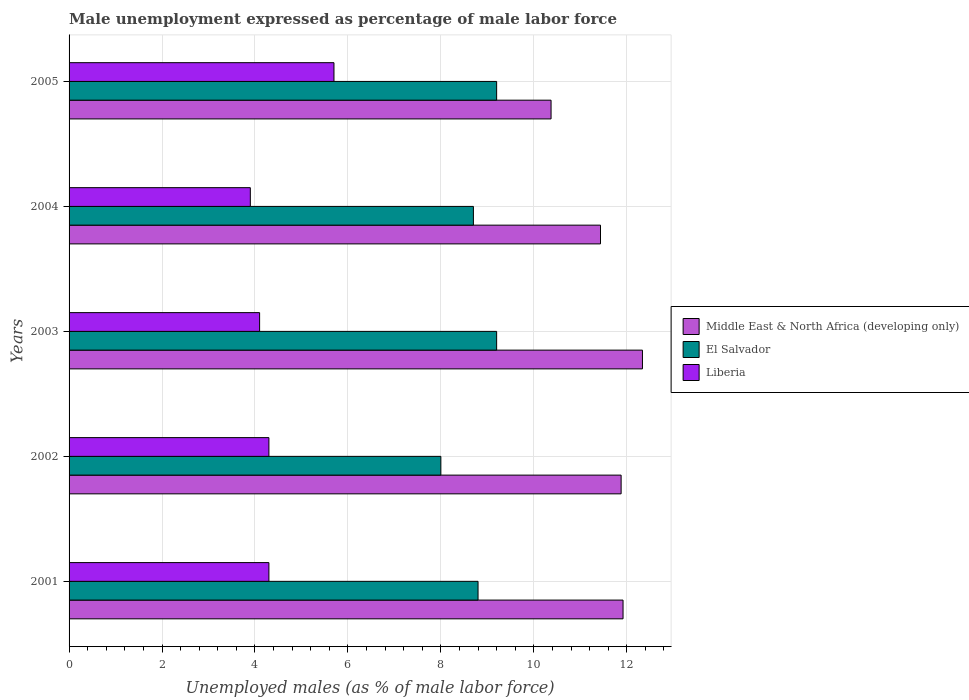How many different coloured bars are there?
Your answer should be compact. 3. What is the label of the 3rd group of bars from the top?
Your answer should be compact. 2003. In how many cases, is the number of bars for a given year not equal to the number of legend labels?
Your response must be concise. 0. What is the unemployment in males in in Middle East & North Africa (developing only) in 2005?
Offer a terse response. 10.37. Across all years, what is the maximum unemployment in males in in Liberia?
Give a very brief answer. 5.7. Across all years, what is the minimum unemployment in males in in Middle East & North Africa (developing only)?
Your answer should be very brief. 10.37. What is the total unemployment in males in in El Salvador in the graph?
Provide a short and direct response. 43.9. What is the difference between the unemployment in males in in El Salvador in 2001 and that in 2002?
Provide a short and direct response. 0.8. What is the difference between the unemployment in males in in Liberia in 2001 and the unemployment in males in in Middle East & North Africa (developing only) in 2002?
Your answer should be very brief. -7.58. What is the average unemployment in males in in El Salvador per year?
Your answer should be compact. 8.78. In the year 2002, what is the difference between the unemployment in males in in Liberia and unemployment in males in in El Salvador?
Offer a very short reply. -3.7. In how many years, is the unemployment in males in in El Salvador greater than 1.2000000000000002 %?
Ensure brevity in your answer.  5. What is the ratio of the unemployment in males in in Middle East & North Africa (developing only) in 2001 to that in 2005?
Offer a terse response. 1.15. Is the unemployment in males in in El Salvador in 2003 less than that in 2005?
Provide a succinct answer. No. Is the difference between the unemployment in males in in Liberia in 2003 and 2004 greater than the difference between the unemployment in males in in El Salvador in 2003 and 2004?
Offer a very short reply. No. What is the difference between the highest and the lowest unemployment in males in in El Salvador?
Your answer should be very brief. 1.2. In how many years, is the unemployment in males in in Liberia greater than the average unemployment in males in in Liberia taken over all years?
Give a very brief answer. 1. Is the sum of the unemployment in males in in Liberia in 2003 and 2005 greater than the maximum unemployment in males in in El Salvador across all years?
Keep it short and to the point. Yes. What does the 3rd bar from the top in 2003 represents?
Offer a terse response. Middle East & North Africa (developing only). What does the 2nd bar from the bottom in 2001 represents?
Offer a very short reply. El Salvador. Is it the case that in every year, the sum of the unemployment in males in in El Salvador and unemployment in males in in Middle East & North Africa (developing only) is greater than the unemployment in males in in Liberia?
Keep it short and to the point. Yes. Are all the bars in the graph horizontal?
Keep it short and to the point. Yes. How many years are there in the graph?
Provide a succinct answer. 5. What is the difference between two consecutive major ticks on the X-axis?
Provide a short and direct response. 2. Are the values on the major ticks of X-axis written in scientific E-notation?
Your response must be concise. No. Does the graph contain any zero values?
Your answer should be very brief. No. Does the graph contain grids?
Your response must be concise. Yes. How are the legend labels stacked?
Your response must be concise. Vertical. What is the title of the graph?
Keep it short and to the point. Male unemployment expressed as percentage of male labor force. What is the label or title of the X-axis?
Give a very brief answer. Unemployed males (as % of male labor force). What is the label or title of the Y-axis?
Provide a short and direct response. Years. What is the Unemployed males (as % of male labor force) in Middle East & North Africa (developing only) in 2001?
Offer a terse response. 11.92. What is the Unemployed males (as % of male labor force) in El Salvador in 2001?
Offer a terse response. 8.8. What is the Unemployed males (as % of male labor force) in Liberia in 2001?
Provide a succinct answer. 4.3. What is the Unemployed males (as % of male labor force) in Middle East & North Africa (developing only) in 2002?
Ensure brevity in your answer.  11.88. What is the Unemployed males (as % of male labor force) in Liberia in 2002?
Offer a terse response. 4.3. What is the Unemployed males (as % of male labor force) of Middle East & North Africa (developing only) in 2003?
Your response must be concise. 12.34. What is the Unemployed males (as % of male labor force) of El Salvador in 2003?
Your response must be concise. 9.2. What is the Unemployed males (as % of male labor force) of Liberia in 2003?
Your answer should be very brief. 4.1. What is the Unemployed males (as % of male labor force) of Middle East & North Africa (developing only) in 2004?
Ensure brevity in your answer.  11.43. What is the Unemployed males (as % of male labor force) in El Salvador in 2004?
Provide a short and direct response. 8.7. What is the Unemployed males (as % of male labor force) of Liberia in 2004?
Provide a short and direct response. 3.9. What is the Unemployed males (as % of male labor force) of Middle East & North Africa (developing only) in 2005?
Make the answer very short. 10.37. What is the Unemployed males (as % of male labor force) in El Salvador in 2005?
Your answer should be compact. 9.2. What is the Unemployed males (as % of male labor force) of Liberia in 2005?
Provide a succinct answer. 5.7. Across all years, what is the maximum Unemployed males (as % of male labor force) in Middle East & North Africa (developing only)?
Your response must be concise. 12.34. Across all years, what is the maximum Unemployed males (as % of male labor force) in El Salvador?
Ensure brevity in your answer.  9.2. Across all years, what is the maximum Unemployed males (as % of male labor force) of Liberia?
Ensure brevity in your answer.  5.7. Across all years, what is the minimum Unemployed males (as % of male labor force) of Middle East & North Africa (developing only)?
Offer a terse response. 10.37. Across all years, what is the minimum Unemployed males (as % of male labor force) of Liberia?
Your answer should be very brief. 3.9. What is the total Unemployed males (as % of male labor force) in Middle East & North Africa (developing only) in the graph?
Your response must be concise. 57.94. What is the total Unemployed males (as % of male labor force) in El Salvador in the graph?
Your answer should be compact. 43.9. What is the total Unemployed males (as % of male labor force) of Liberia in the graph?
Give a very brief answer. 22.3. What is the difference between the Unemployed males (as % of male labor force) of Middle East & North Africa (developing only) in 2001 and that in 2002?
Provide a succinct answer. 0.04. What is the difference between the Unemployed males (as % of male labor force) in Liberia in 2001 and that in 2002?
Keep it short and to the point. 0. What is the difference between the Unemployed males (as % of male labor force) in Middle East & North Africa (developing only) in 2001 and that in 2003?
Provide a short and direct response. -0.42. What is the difference between the Unemployed males (as % of male labor force) of Liberia in 2001 and that in 2003?
Keep it short and to the point. 0.2. What is the difference between the Unemployed males (as % of male labor force) of Middle East & North Africa (developing only) in 2001 and that in 2004?
Give a very brief answer. 0.49. What is the difference between the Unemployed males (as % of male labor force) of El Salvador in 2001 and that in 2004?
Give a very brief answer. 0.1. What is the difference between the Unemployed males (as % of male labor force) of Middle East & North Africa (developing only) in 2001 and that in 2005?
Your answer should be very brief. 1.55. What is the difference between the Unemployed males (as % of male labor force) in Liberia in 2001 and that in 2005?
Give a very brief answer. -1.4. What is the difference between the Unemployed males (as % of male labor force) of Middle East & North Africa (developing only) in 2002 and that in 2003?
Make the answer very short. -0.46. What is the difference between the Unemployed males (as % of male labor force) of El Salvador in 2002 and that in 2003?
Provide a short and direct response. -1.2. What is the difference between the Unemployed males (as % of male labor force) in Middle East & North Africa (developing only) in 2002 and that in 2004?
Provide a succinct answer. 0.44. What is the difference between the Unemployed males (as % of male labor force) of Liberia in 2002 and that in 2004?
Provide a short and direct response. 0.4. What is the difference between the Unemployed males (as % of male labor force) of Middle East & North Africa (developing only) in 2002 and that in 2005?
Make the answer very short. 1.51. What is the difference between the Unemployed males (as % of male labor force) of Liberia in 2002 and that in 2005?
Give a very brief answer. -1.4. What is the difference between the Unemployed males (as % of male labor force) of Middle East & North Africa (developing only) in 2003 and that in 2004?
Offer a terse response. 0.9. What is the difference between the Unemployed males (as % of male labor force) in Liberia in 2003 and that in 2004?
Make the answer very short. 0.2. What is the difference between the Unemployed males (as % of male labor force) in Middle East & North Africa (developing only) in 2003 and that in 2005?
Offer a terse response. 1.97. What is the difference between the Unemployed males (as % of male labor force) in El Salvador in 2003 and that in 2005?
Your answer should be very brief. 0. What is the difference between the Unemployed males (as % of male labor force) of Liberia in 2003 and that in 2005?
Make the answer very short. -1.6. What is the difference between the Unemployed males (as % of male labor force) of Middle East & North Africa (developing only) in 2004 and that in 2005?
Ensure brevity in your answer.  1.06. What is the difference between the Unemployed males (as % of male labor force) in El Salvador in 2004 and that in 2005?
Your answer should be compact. -0.5. What is the difference between the Unemployed males (as % of male labor force) of Liberia in 2004 and that in 2005?
Provide a succinct answer. -1.8. What is the difference between the Unemployed males (as % of male labor force) of Middle East & North Africa (developing only) in 2001 and the Unemployed males (as % of male labor force) of El Salvador in 2002?
Give a very brief answer. 3.92. What is the difference between the Unemployed males (as % of male labor force) in Middle East & North Africa (developing only) in 2001 and the Unemployed males (as % of male labor force) in Liberia in 2002?
Offer a very short reply. 7.62. What is the difference between the Unemployed males (as % of male labor force) of Middle East & North Africa (developing only) in 2001 and the Unemployed males (as % of male labor force) of El Salvador in 2003?
Offer a terse response. 2.72. What is the difference between the Unemployed males (as % of male labor force) of Middle East & North Africa (developing only) in 2001 and the Unemployed males (as % of male labor force) of Liberia in 2003?
Ensure brevity in your answer.  7.82. What is the difference between the Unemployed males (as % of male labor force) of Middle East & North Africa (developing only) in 2001 and the Unemployed males (as % of male labor force) of El Salvador in 2004?
Offer a very short reply. 3.22. What is the difference between the Unemployed males (as % of male labor force) in Middle East & North Africa (developing only) in 2001 and the Unemployed males (as % of male labor force) in Liberia in 2004?
Your answer should be compact. 8.02. What is the difference between the Unemployed males (as % of male labor force) in Middle East & North Africa (developing only) in 2001 and the Unemployed males (as % of male labor force) in El Salvador in 2005?
Offer a terse response. 2.72. What is the difference between the Unemployed males (as % of male labor force) of Middle East & North Africa (developing only) in 2001 and the Unemployed males (as % of male labor force) of Liberia in 2005?
Make the answer very short. 6.22. What is the difference between the Unemployed males (as % of male labor force) of El Salvador in 2001 and the Unemployed males (as % of male labor force) of Liberia in 2005?
Give a very brief answer. 3.1. What is the difference between the Unemployed males (as % of male labor force) in Middle East & North Africa (developing only) in 2002 and the Unemployed males (as % of male labor force) in El Salvador in 2003?
Offer a very short reply. 2.68. What is the difference between the Unemployed males (as % of male labor force) in Middle East & North Africa (developing only) in 2002 and the Unemployed males (as % of male labor force) in Liberia in 2003?
Your answer should be compact. 7.78. What is the difference between the Unemployed males (as % of male labor force) of El Salvador in 2002 and the Unemployed males (as % of male labor force) of Liberia in 2003?
Keep it short and to the point. 3.9. What is the difference between the Unemployed males (as % of male labor force) in Middle East & North Africa (developing only) in 2002 and the Unemployed males (as % of male labor force) in El Salvador in 2004?
Ensure brevity in your answer.  3.18. What is the difference between the Unemployed males (as % of male labor force) in Middle East & North Africa (developing only) in 2002 and the Unemployed males (as % of male labor force) in Liberia in 2004?
Your response must be concise. 7.98. What is the difference between the Unemployed males (as % of male labor force) of El Salvador in 2002 and the Unemployed males (as % of male labor force) of Liberia in 2004?
Provide a succinct answer. 4.1. What is the difference between the Unemployed males (as % of male labor force) of Middle East & North Africa (developing only) in 2002 and the Unemployed males (as % of male labor force) of El Salvador in 2005?
Keep it short and to the point. 2.68. What is the difference between the Unemployed males (as % of male labor force) of Middle East & North Africa (developing only) in 2002 and the Unemployed males (as % of male labor force) of Liberia in 2005?
Your response must be concise. 6.18. What is the difference between the Unemployed males (as % of male labor force) in El Salvador in 2002 and the Unemployed males (as % of male labor force) in Liberia in 2005?
Your response must be concise. 2.3. What is the difference between the Unemployed males (as % of male labor force) in Middle East & North Africa (developing only) in 2003 and the Unemployed males (as % of male labor force) in El Salvador in 2004?
Your answer should be compact. 3.64. What is the difference between the Unemployed males (as % of male labor force) in Middle East & North Africa (developing only) in 2003 and the Unemployed males (as % of male labor force) in Liberia in 2004?
Your response must be concise. 8.44. What is the difference between the Unemployed males (as % of male labor force) in El Salvador in 2003 and the Unemployed males (as % of male labor force) in Liberia in 2004?
Make the answer very short. 5.3. What is the difference between the Unemployed males (as % of male labor force) in Middle East & North Africa (developing only) in 2003 and the Unemployed males (as % of male labor force) in El Salvador in 2005?
Provide a short and direct response. 3.14. What is the difference between the Unemployed males (as % of male labor force) in Middle East & North Africa (developing only) in 2003 and the Unemployed males (as % of male labor force) in Liberia in 2005?
Offer a very short reply. 6.64. What is the difference between the Unemployed males (as % of male labor force) in Middle East & North Africa (developing only) in 2004 and the Unemployed males (as % of male labor force) in El Salvador in 2005?
Ensure brevity in your answer.  2.23. What is the difference between the Unemployed males (as % of male labor force) in Middle East & North Africa (developing only) in 2004 and the Unemployed males (as % of male labor force) in Liberia in 2005?
Offer a terse response. 5.73. What is the average Unemployed males (as % of male labor force) of Middle East & North Africa (developing only) per year?
Your answer should be very brief. 11.59. What is the average Unemployed males (as % of male labor force) of El Salvador per year?
Ensure brevity in your answer.  8.78. What is the average Unemployed males (as % of male labor force) of Liberia per year?
Provide a short and direct response. 4.46. In the year 2001, what is the difference between the Unemployed males (as % of male labor force) in Middle East & North Africa (developing only) and Unemployed males (as % of male labor force) in El Salvador?
Offer a very short reply. 3.12. In the year 2001, what is the difference between the Unemployed males (as % of male labor force) of Middle East & North Africa (developing only) and Unemployed males (as % of male labor force) of Liberia?
Ensure brevity in your answer.  7.62. In the year 2002, what is the difference between the Unemployed males (as % of male labor force) of Middle East & North Africa (developing only) and Unemployed males (as % of male labor force) of El Salvador?
Make the answer very short. 3.88. In the year 2002, what is the difference between the Unemployed males (as % of male labor force) of Middle East & North Africa (developing only) and Unemployed males (as % of male labor force) of Liberia?
Your answer should be compact. 7.58. In the year 2002, what is the difference between the Unemployed males (as % of male labor force) of El Salvador and Unemployed males (as % of male labor force) of Liberia?
Make the answer very short. 3.7. In the year 2003, what is the difference between the Unemployed males (as % of male labor force) of Middle East & North Africa (developing only) and Unemployed males (as % of male labor force) of El Salvador?
Give a very brief answer. 3.14. In the year 2003, what is the difference between the Unemployed males (as % of male labor force) in Middle East & North Africa (developing only) and Unemployed males (as % of male labor force) in Liberia?
Your answer should be very brief. 8.24. In the year 2004, what is the difference between the Unemployed males (as % of male labor force) of Middle East & North Africa (developing only) and Unemployed males (as % of male labor force) of El Salvador?
Offer a terse response. 2.73. In the year 2004, what is the difference between the Unemployed males (as % of male labor force) in Middle East & North Africa (developing only) and Unemployed males (as % of male labor force) in Liberia?
Provide a short and direct response. 7.53. In the year 2005, what is the difference between the Unemployed males (as % of male labor force) of Middle East & North Africa (developing only) and Unemployed males (as % of male labor force) of El Salvador?
Offer a terse response. 1.17. In the year 2005, what is the difference between the Unemployed males (as % of male labor force) in Middle East & North Africa (developing only) and Unemployed males (as % of male labor force) in Liberia?
Provide a short and direct response. 4.67. What is the ratio of the Unemployed males (as % of male labor force) of Middle East & North Africa (developing only) in 2001 to that in 2002?
Provide a succinct answer. 1. What is the ratio of the Unemployed males (as % of male labor force) of Middle East & North Africa (developing only) in 2001 to that in 2003?
Your answer should be very brief. 0.97. What is the ratio of the Unemployed males (as % of male labor force) in El Salvador in 2001 to that in 2003?
Provide a succinct answer. 0.96. What is the ratio of the Unemployed males (as % of male labor force) of Liberia in 2001 to that in 2003?
Provide a short and direct response. 1.05. What is the ratio of the Unemployed males (as % of male labor force) of Middle East & North Africa (developing only) in 2001 to that in 2004?
Provide a short and direct response. 1.04. What is the ratio of the Unemployed males (as % of male labor force) of El Salvador in 2001 to that in 2004?
Your response must be concise. 1.01. What is the ratio of the Unemployed males (as % of male labor force) of Liberia in 2001 to that in 2004?
Your answer should be very brief. 1.1. What is the ratio of the Unemployed males (as % of male labor force) in Middle East & North Africa (developing only) in 2001 to that in 2005?
Ensure brevity in your answer.  1.15. What is the ratio of the Unemployed males (as % of male labor force) of El Salvador in 2001 to that in 2005?
Give a very brief answer. 0.96. What is the ratio of the Unemployed males (as % of male labor force) in Liberia in 2001 to that in 2005?
Make the answer very short. 0.75. What is the ratio of the Unemployed males (as % of male labor force) of Middle East & North Africa (developing only) in 2002 to that in 2003?
Provide a short and direct response. 0.96. What is the ratio of the Unemployed males (as % of male labor force) of El Salvador in 2002 to that in 2003?
Make the answer very short. 0.87. What is the ratio of the Unemployed males (as % of male labor force) of Liberia in 2002 to that in 2003?
Keep it short and to the point. 1.05. What is the ratio of the Unemployed males (as % of male labor force) in Middle East & North Africa (developing only) in 2002 to that in 2004?
Keep it short and to the point. 1.04. What is the ratio of the Unemployed males (as % of male labor force) in El Salvador in 2002 to that in 2004?
Keep it short and to the point. 0.92. What is the ratio of the Unemployed males (as % of male labor force) in Liberia in 2002 to that in 2004?
Your answer should be very brief. 1.1. What is the ratio of the Unemployed males (as % of male labor force) in Middle East & North Africa (developing only) in 2002 to that in 2005?
Provide a succinct answer. 1.15. What is the ratio of the Unemployed males (as % of male labor force) of El Salvador in 2002 to that in 2005?
Ensure brevity in your answer.  0.87. What is the ratio of the Unemployed males (as % of male labor force) in Liberia in 2002 to that in 2005?
Your answer should be very brief. 0.75. What is the ratio of the Unemployed males (as % of male labor force) of Middle East & North Africa (developing only) in 2003 to that in 2004?
Ensure brevity in your answer.  1.08. What is the ratio of the Unemployed males (as % of male labor force) in El Salvador in 2003 to that in 2004?
Ensure brevity in your answer.  1.06. What is the ratio of the Unemployed males (as % of male labor force) of Liberia in 2003 to that in 2004?
Offer a terse response. 1.05. What is the ratio of the Unemployed males (as % of male labor force) in Middle East & North Africa (developing only) in 2003 to that in 2005?
Provide a short and direct response. 1.19. What is the ratio of the Unemployed males (as % of male labor force) of El Salvador in 2003 to that in 2005?
Offer a very short reply. 1. What is the ratio of the Unemployed males (as % of male labor force) in Liberia in 2003 to that in 2005?
Keep it short and to the point. 0.72. What is the ratio of the Unemployed males (as % of male labor force) of Middle East & North Africa (developing only) in 2004 to that in 2005?
Make the answer very short. 1.1. What is the ratio of the Unemployed males (as % of male labor force) of El Salvador in 2004 to that in 2005?
Ensure brevity in your answer.  0.95. What is the ratio of the Unemployed males (as % of male labor force) in Liberia in 2004 to that in 2005?
Your response must be concise. 0.68. What is the difference between the highest and the second highest Unemployed males (as % of male labor force) in Middle East & North Africa (developing only)?
Ensure brevity in your answer.  0.42. What is the difference between the highest and the second highest Unemployed males (as % of male labor force) in El Salvador?
Give a very brief answer. 0. What is the difference between the highest and the lowest Unemployed males (as % of male labor force) in Middle East & North Africa (developing only)?
Your answer should be very brief. 1.97. What is the difference between the highest and the lowest Unemployed males (as % of male labor force) of El Salvador?
Give a very brief answer. 1.2. 